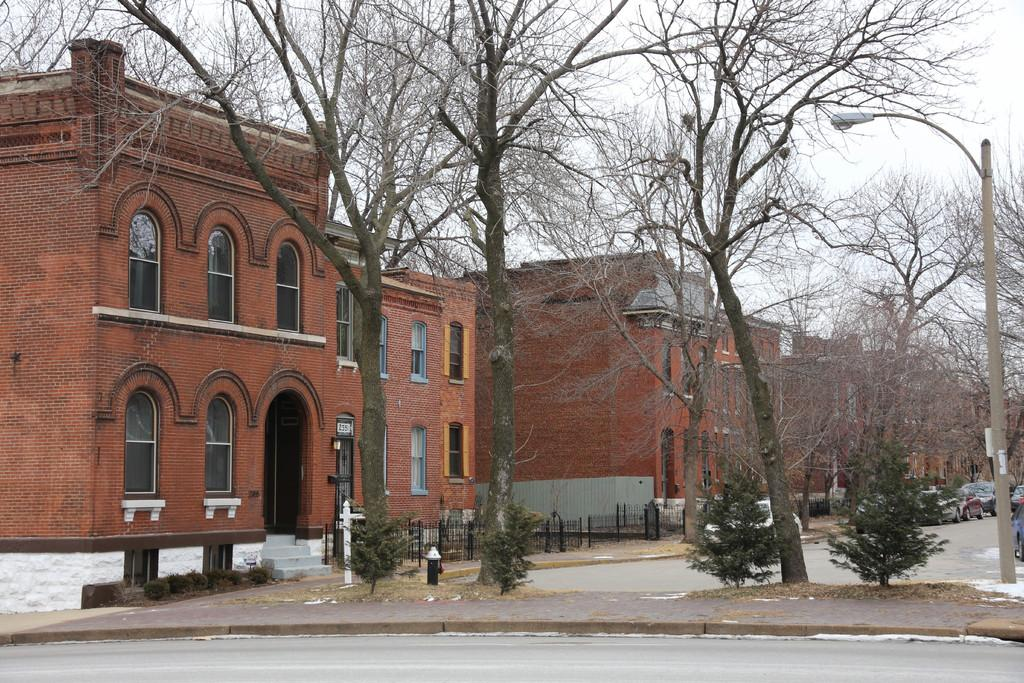What type of pathway can be seen in the image? There is a road in the image. What safety feature is present in the image? A fire hydrant is present in the image. What type of vegetation is visible in the image? There are trees in the image. What type of structure is visible in the image? A light pole is visible in the image. What type of barrier is present in the image? There is a fence in the image. What type of buildings are present in the image? Brick buildings are present in the image. What type of vehicles are parked in the image? Cars are parked in the image. What can be seen in the background of the image? The sky is visible in the background of the image. Where is the boot located in the image? There is no boot present in the image. What type of utensil is being used to eat the salad in the image? There is no salad or fork present in the image. What type of frozen water formation can be seen hanging from the light pole in the image? There is no icicle present in the image. 